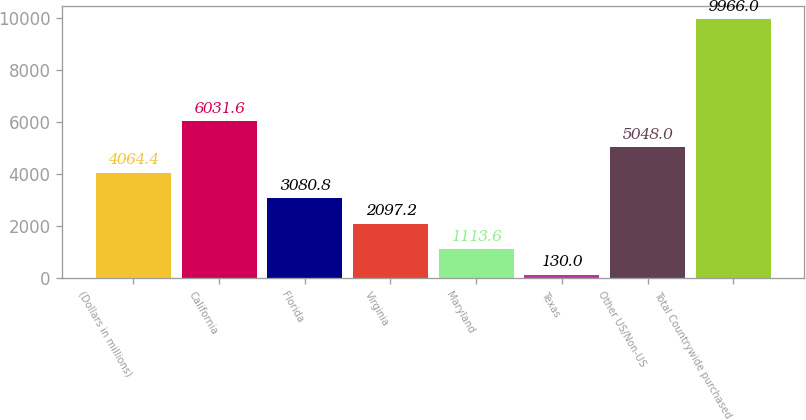<chart> <loc_0><loc_0><loc_500><loc_500><bar_chart><fcel>(Dollars in millions)<fcel>California<fcel>Florida<fcel>Virginia<fcel>Maryland<fcel>Texas<fcel>Other US/Non-US<fcel>Total Countrywide purchased<nl><fcel>4064.4<fcel>6031.6<fcel>3080.8<fcel>2097.2<fcel>1113.6<fcel>130<fcel>5048<fcel>9966<nl></chart> 